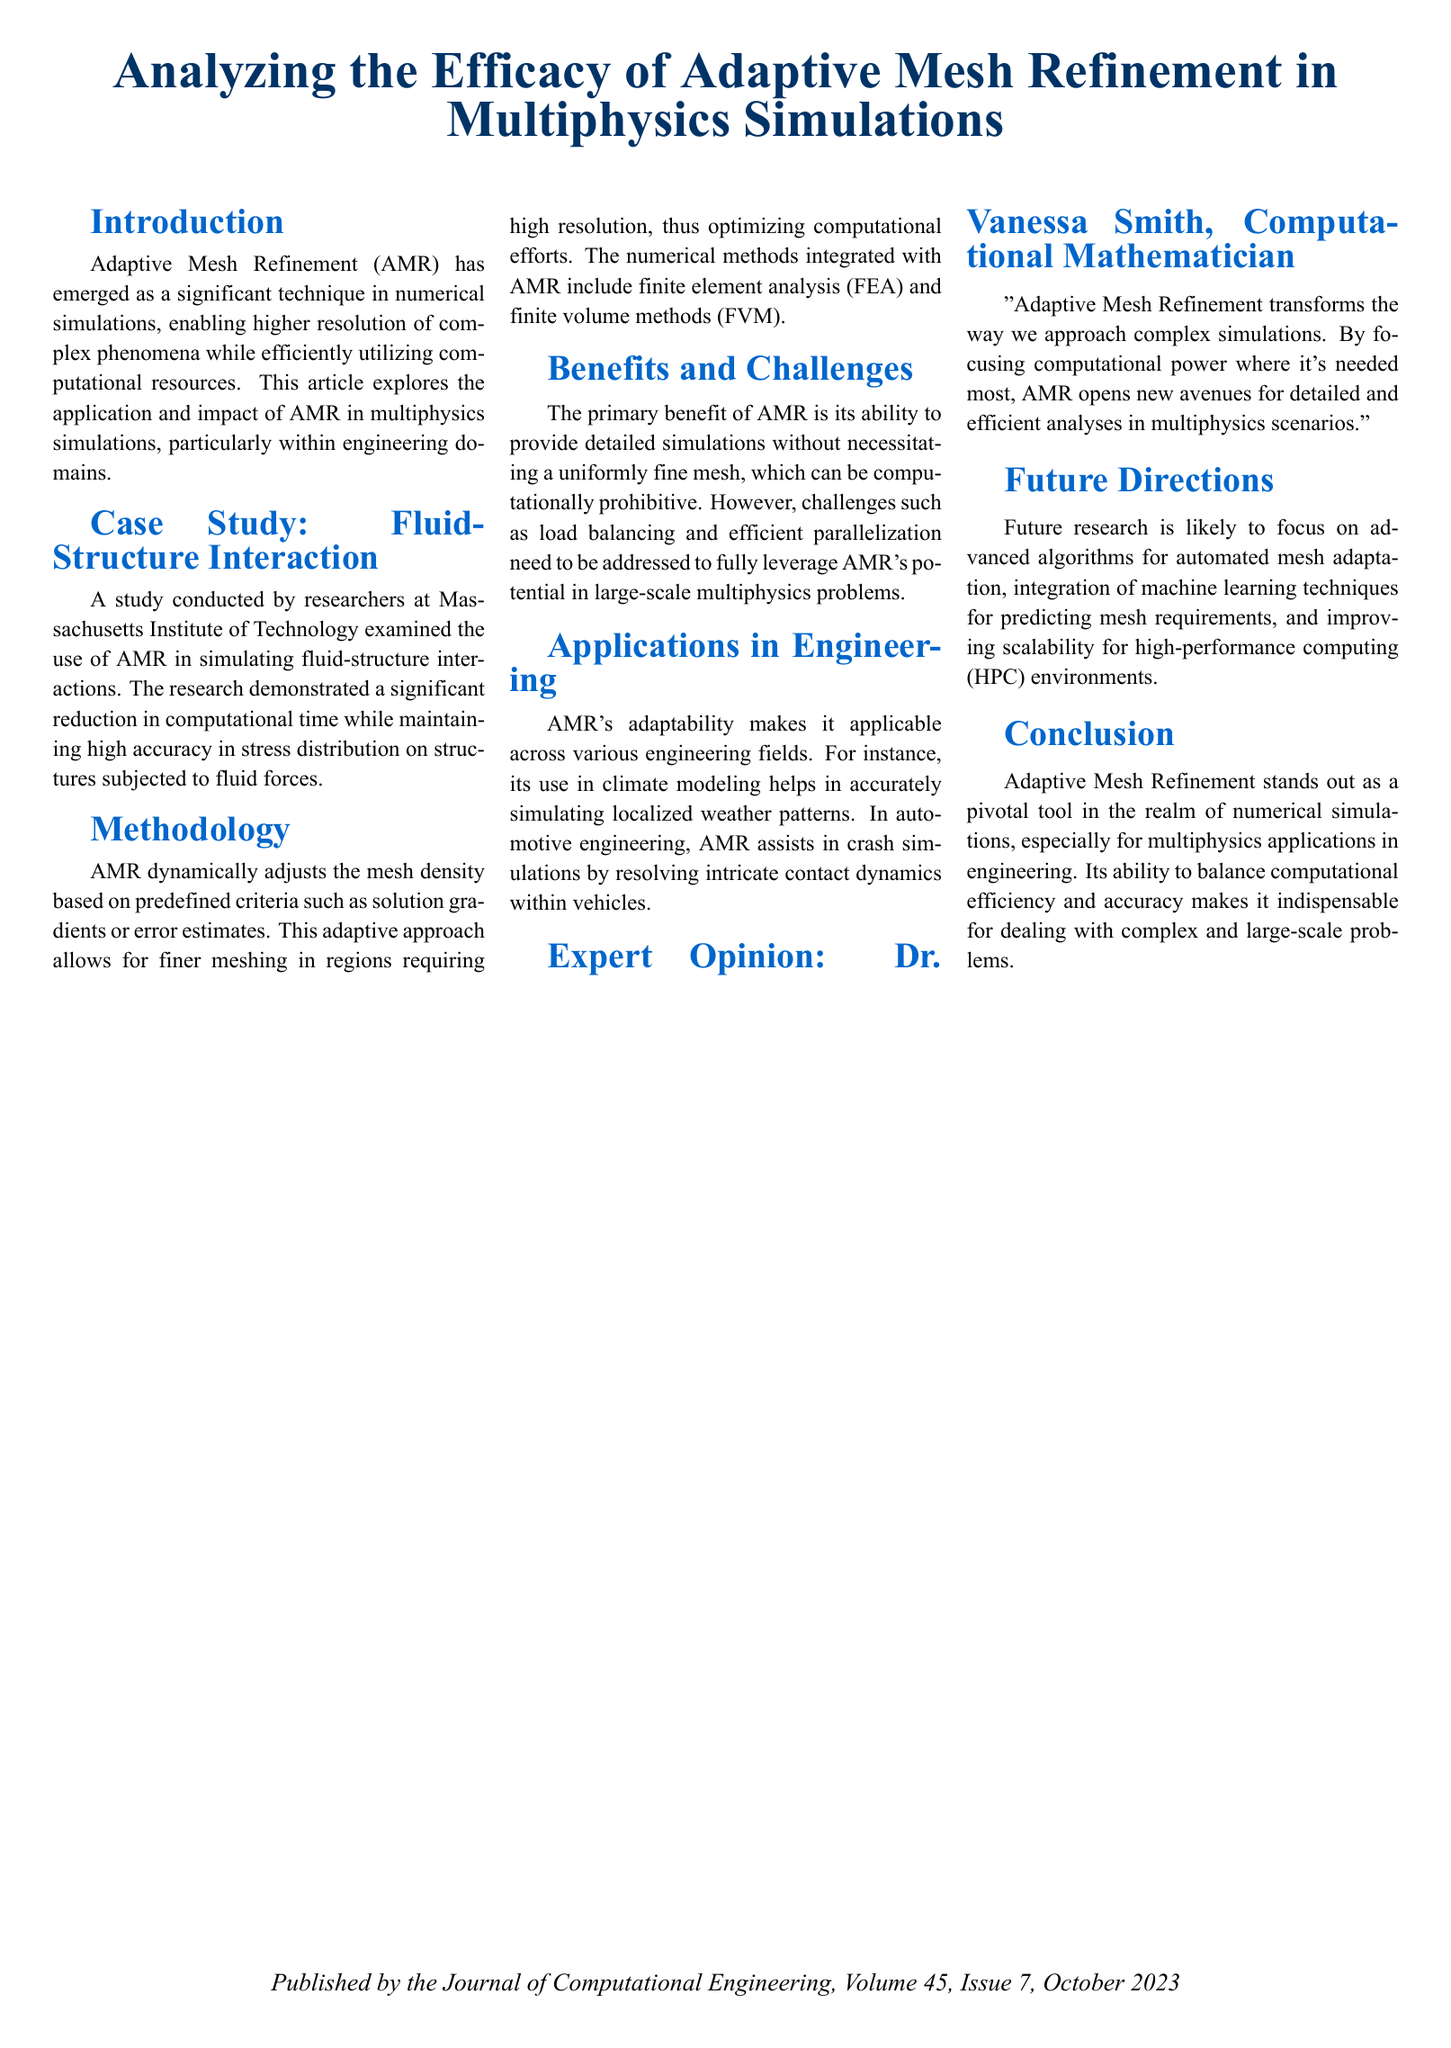What is the primary benefit of Adaptive Mesh Refinement? The primary benefit of AMR is its ability to provide detailed simulations without necessitating a uniformly fine mesh.
Answer: Detailed simulations without a uniformly fine mesh Who conducted the case study on Fluid-Structure Interaction? The study on Fluid-Structure Interaction was conducted by researchers at Massachusetts Institute of Technology.
Answer: Massachusetts Institute of Technology Which numerical methods integrate with AMR? The numerical methods integrated with AMR include finite element analysis (FEA) and finite volume methods (FVM).
Answer: Finite element analysis (FEA) and finite volume methods (FVM) What is identified as a key future direction for AMR research? Future research is likely to focus on advanced algorithms for automated mesh adaptation.
Answer: Advanced algorithms for automated mesh adaptation What is the publication date of the document? The document is published in October 2023.
Answer: October 2023 What is the title of the article? The title of the article is "Analyzing the Efficacy of Adaptive Mesh Refinement in Multiphysics Simulations".
Answer: Analyzing the Efficacy of Adaptive Mesh Refinement in Multiphysics Simulations 